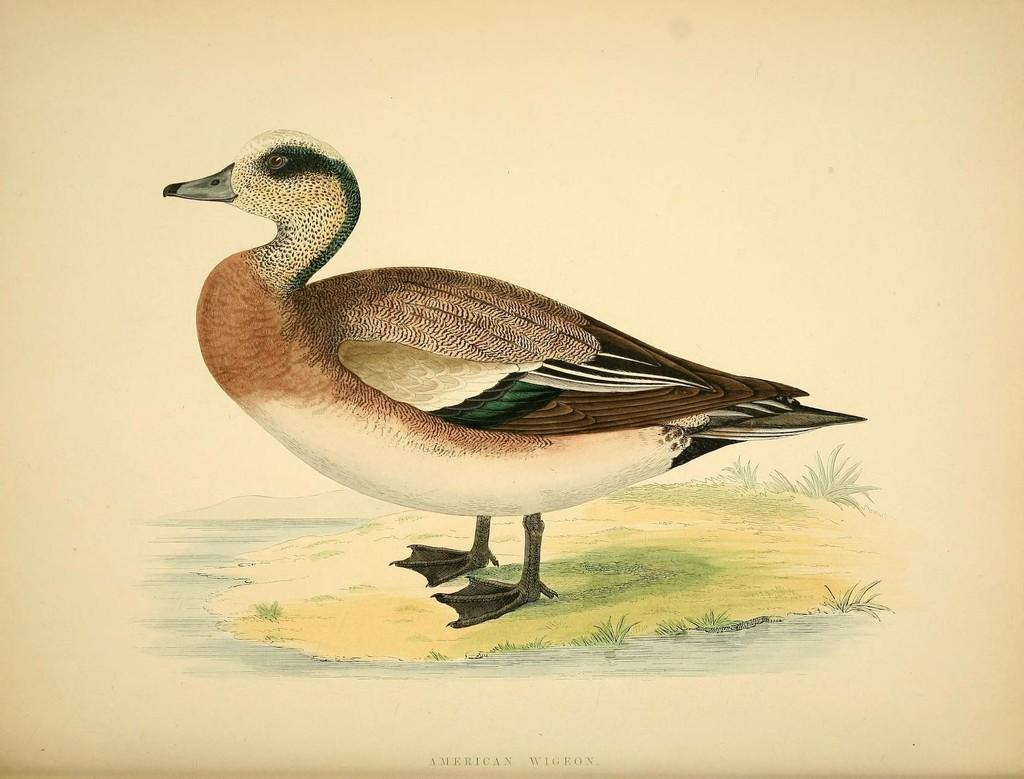What is the main subject of the poster in the image? There is a duck depicted on the poster in the image. Where is the text located in the image? The text is at the bottom of the image. What type of clouds are depicted in the image? There are no clouds depicted in the image; it features a poster with a duck and text. Is this a birthday party poster, and if so, what does the text say? The image does not indicate that it is a birthday party poster, and we cannot determine the text's content without more information. 